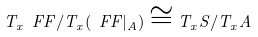Convert formula to latex. <formula><loc_0><loc_0><loc_500><loc_500>T _ { x } \ F F / T _ { x } ( \ F F | _ { A } ) \cong T _ { x } S / T _ { x } A</formula> 